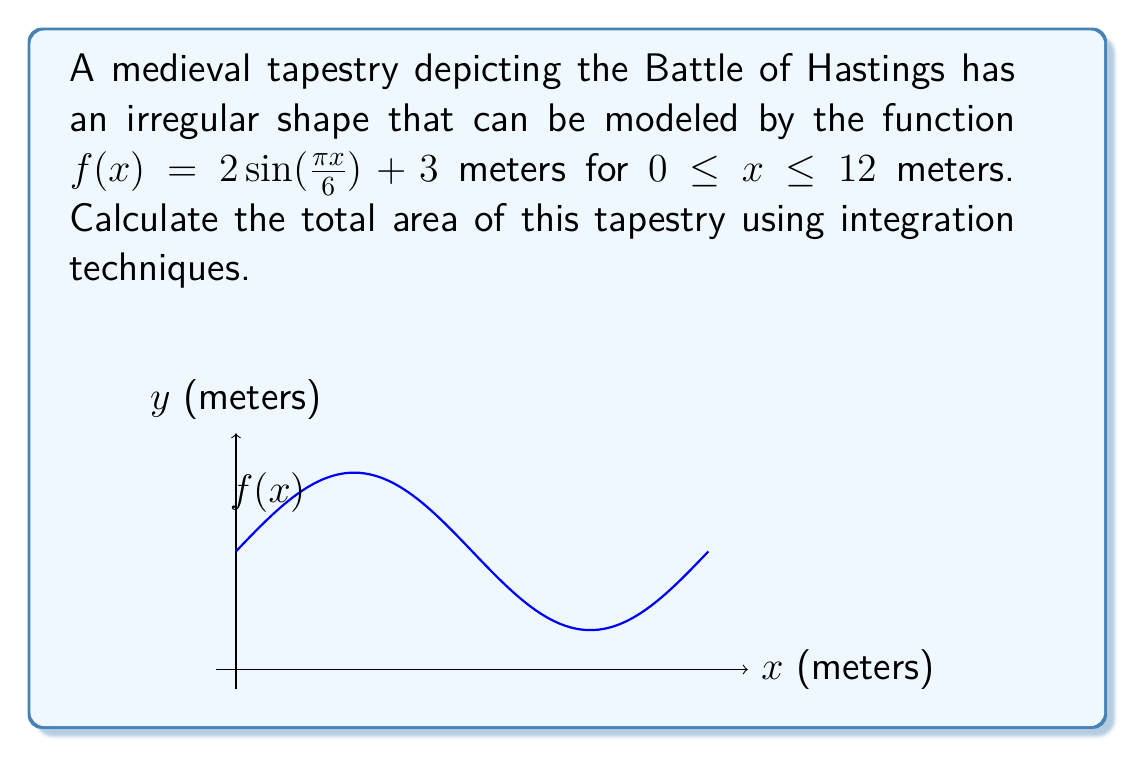Help me with this question. To find the area of this irregular-shaped tapestry, we need to use definite integration. The steps are as follows:

1) The area under a curve $y = f(x)$ from $a$ to $b$ is given by the definite integral:

   $$A = \int_{a}^{b} f(x) dx$$

2) In this case, $f(x) = 2\sin(\frac{\pi x}{6}) + 3$, $a = 0$, and $b = 12$. So our integral becomes:

   $$A = \int_{0}^{12} (2\sin(\frac{\pi x}{6}) + 3) dx$$

3) We can split this into two integrals:

   $$A = \int_{0}^{12} 2\sin(\frac{\pi x}{6}) dx + \int_{0}^{12} 3 dx$$

4) For the first integral, we use the substitution $u = \frac{\pi x}{6}$, so $du = \frac{\pi}{6} dx$ or $dx = \frac{6}{\pi} du$. When $x = 0$, $u = 0$, and when $x = 12$, $u = 2\pi$. This gives:

   $$\int_{0}^{12} 2\sin(\frac{\pi x}{6}) dx = \frac{12}{\pi} \int_{0}^{2\pi} \sin(u) du = \frac{12}{\pi} [-\cos(u)]_{0}^{2\pi} = \frac{12}{\pi} [(-\cos(2\pi)) - (-\cos(0))] = 0$$

5) For the second integral:

   $$\int_{0}^{12} 3 dx = [3x]_{0}^{12} = 36$$

6) Adding these results:

   $$A = 0 + 36 = 36$$

Therefore, the total area of the tapestry is 36 square meters.
Answer: 36 m² 